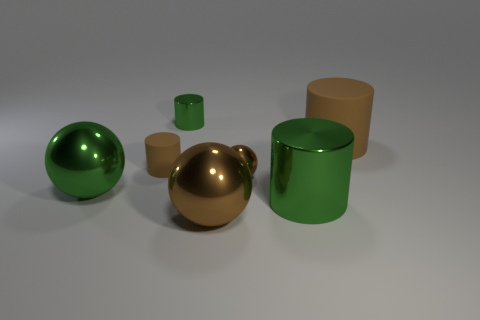Are there fewer tiny green cylinders that are to the right of the big brown matte cylinder than big brown shiny things to the right of the tiny brown cylinder?
Offer a very short reply. Yes. How many small things are made of the same material as the tiny brown cylinder?
Offer a terse response. 0. There is a green sphere; does it have the same size as the brown metallic ball behind the large green metal cylinder?
Give a very brief answer. No. There is a tiny object that is the same color as the tiny metallic ball; what is its material?
Offer a terse response. Rubber. There is a brown cylinder that is in front of the cylinder that is to the right of the green metal cylinder that is in front of the small metallic ball; how big is it?
Provide a succinct answer. Small. Is the number of big rubber cylinders that are in front of the large brown matte object greater than the number of tiny shiny objects that are behind the tiny green thing?
Ensure brevity in your answer.  No. There is a small thing behind the big brown rubber cylinder; what number of large green metallic things are behind it?
Offer a terse response. 0. Are there any tiny rubber objects that have the same color as the large rubber object?
Offer a terse response. Yes. Is the color of the large metal cylinder the same as the tiny matte cylinder?
Provide a short and direct response. No. The cylinder in front of the brown ball behind the green metallic ball is made of what material?
Your response must be concise. Metal. 